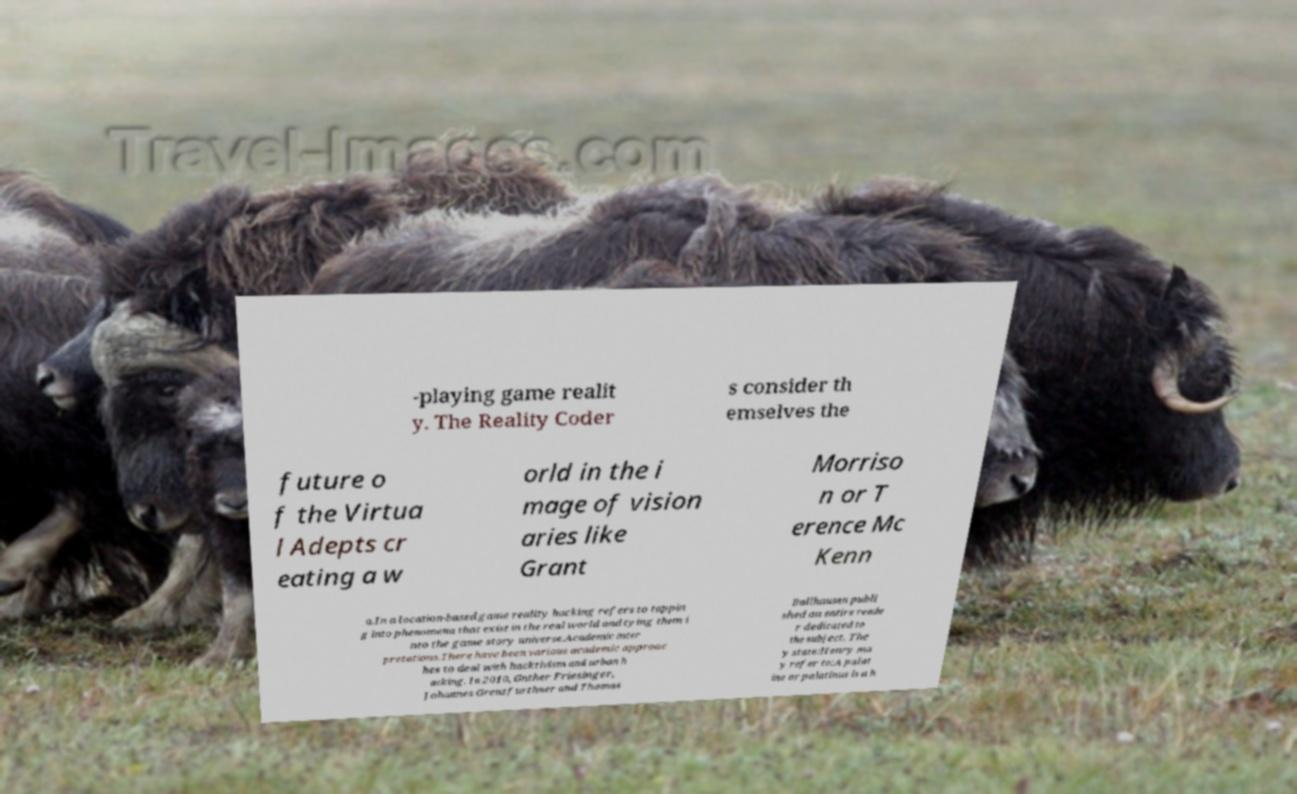Could you assist in decoding the text presented in this image and type it out clearly? -playing game realit y. The Reality Coder s consider th emselves the future o f the Virtua l Adepts cr eating a w orld in the i mage of vision aries like Grant Morriso n or T erence Mc Kenn a.In a location-based game reality hacking refers to tappin g into phenomena that exist in the real world and tying them i nto the game story universe.Academic inter pretations.There have been various academic approac hes to deal with hacktivism and urban h acking. In 2010, Gnther Friesinger, Johannes Grenzfurthner and Thomas Ballhausen publi shed an entire reade r dedicated to the subject. The y state:Henry ma y refer to:A palat ine or palatinus is a h 